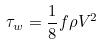Convert formula to latex. <formula><loc_0><loc_0><loc_500><loc_500>\tau _ { w } = \frac { 1 } { 8 } f \rho V ^ { 2 }</formula> 